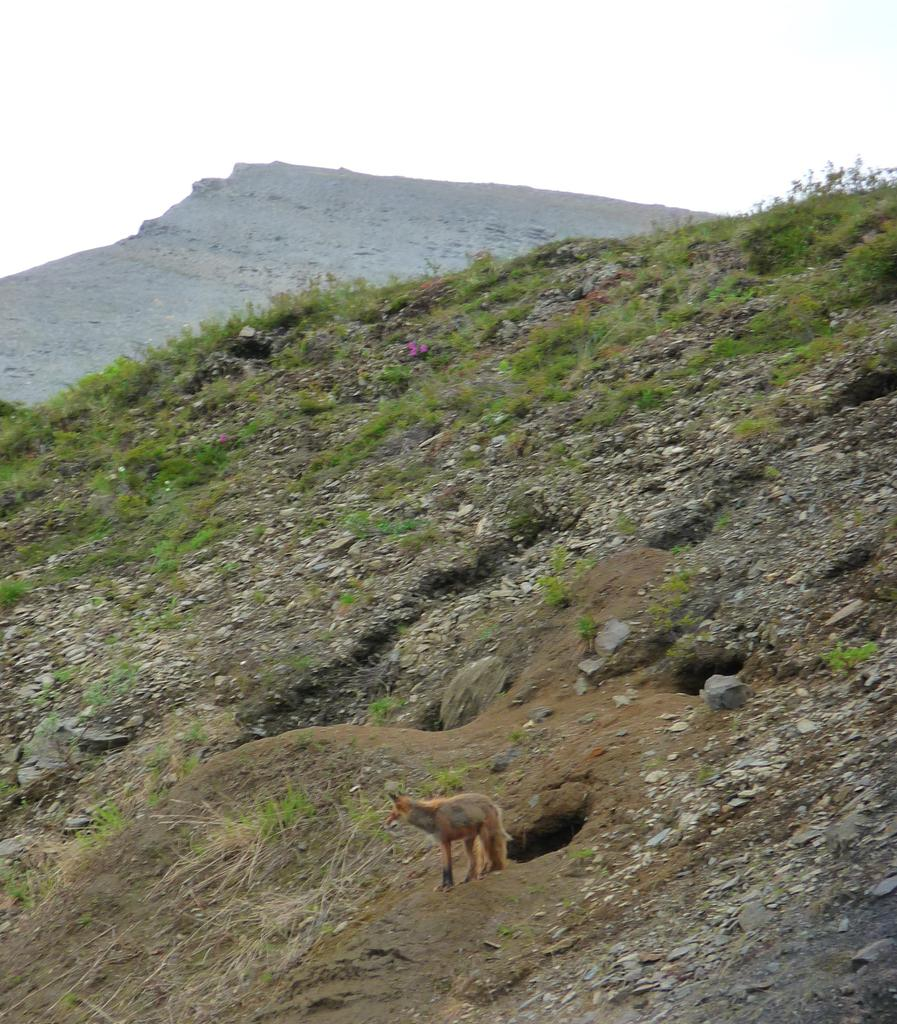What type of vegetation is present on the slope land in the image? There is grass on the slope land in the image. What animal can be seen in the image? There is a fox in the image. What type of geographical feature is visible in the background of the image? There is a mountain in the background of the image. What part of the natural environment is visible in the background of the image? The sky is visible in the background of the image. What type of engine can be seen powering the fox in the image? There is no engine present in the image, and the fox is not powered by any engine. What substance is the fox made of in the image? The fox is a living animal and is made of organic matter, not a substance. 